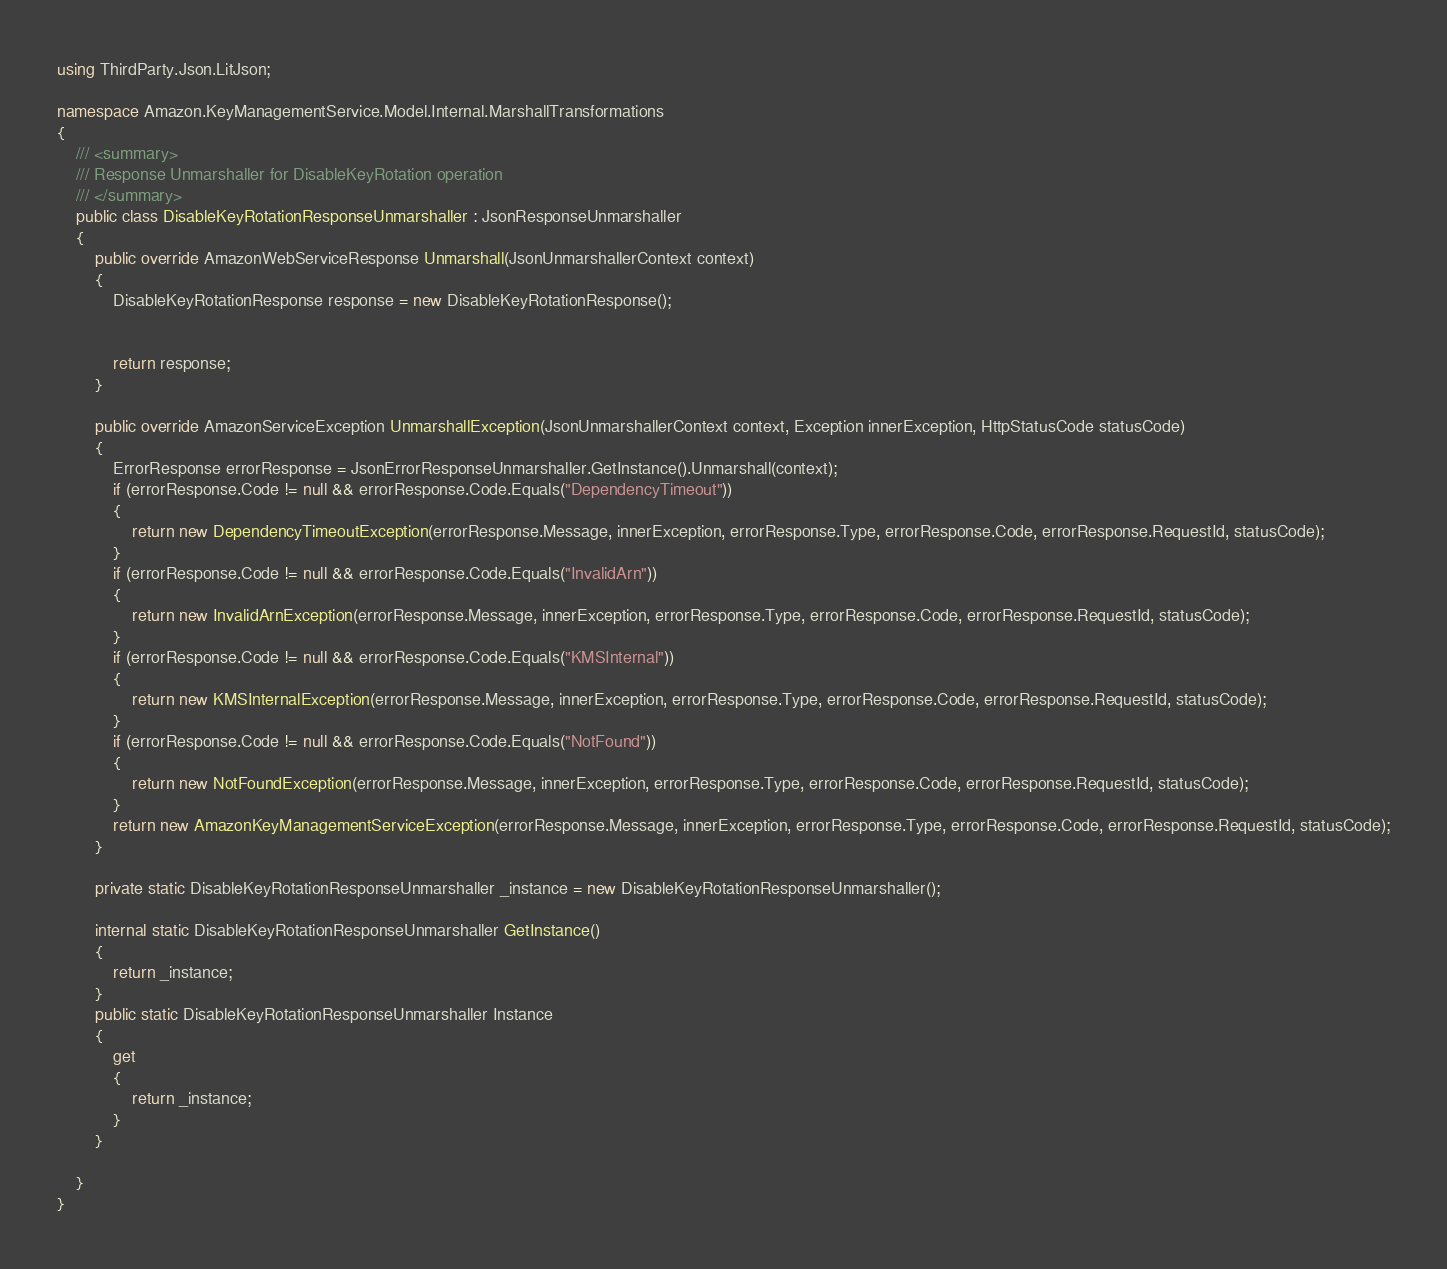<code> <loc_0><loc_0><loc_500><loc_500><_C#_>using ThirdParty.Json.LitJson;

namespace Amazon.KeyManagementService.Model.Internal.MarshallTransformations
{
    /// <summary>
    /// Response Unmarshaller for DisableKeyRotation operation
    /// </summary>  
    public class DisableKeyRotationResponseUnmarshaller : JsonResponseUnmarshaller
    {
        public override AmazonWebServiceResponse Unmarshall(JsonUnmarshallerContext context)
        {
            DisableKeyRotationResponse response = new DisableKeyRotationResponse();


            return response;
        }

        public override AmazonServiceException UnmarshallException(JsonUnmarshallerContext context, Exception innerException, HttpStatusCode statusCode)
        {
            ErrorResponse errorResponse = JsonErrorResponseUnmarshaller.GetInstance().Unmarshall(context);
            if (errorResponse.Code != null && errorResponse.Code.Equals("DependencyTimeout"))
            {
                return new DependencyTimeoutException(errorResponse.Message, innerException, errorResponse.Type, errorResponse.Code, errorResponse.RequestId, statusCode);
            }
            if (errorResponse.Code != null && errorResponse.Code.Equals("InvalidArn"))
            {
                return new InvalidArnException(errorResponse.Message, innerException, errorResponse.Type, errorResponse.Code, errorResponse.RequestId, statusCode);
            }
            if (errorResponse.Code != null && errorResponse.Code.Equals("KMSInternal"))
            {
                return new KMSInternalException(errorResponse.Message, innerException, errorResponse.Type, errorResponse.Code, errorResponse.RequestId, statusCode);
            }
            if (errorResponse.Code != null && errorResponse.Code.Equals("NotFound"))
            {
                return new NotFoundException(errorResponse.Message, innerException, errorResponse.Type, errorResponse.Code, errorResponse.RequestId, statusCode);
            }
            return new AmazonKeyManagementServiceException(errorResponse.Message, innerException, errorResponse.Type, errorResponse.Code, errorResponse.RequestId, statusCode);
        }

        private static DisableKeyRotationResponseUnmarshaller _instance = new DisableKeyRotationResponseUnmarshaller();        

        internal static DisableKeyRotationResponseUnmarshaller GetInstance()
        {
            return _instance;
        }
        public static DisableKeyRotationResponseUnmarshaller Instance
        {
            get
            {
                return _instance;
            }
        }

    }
}</code> 